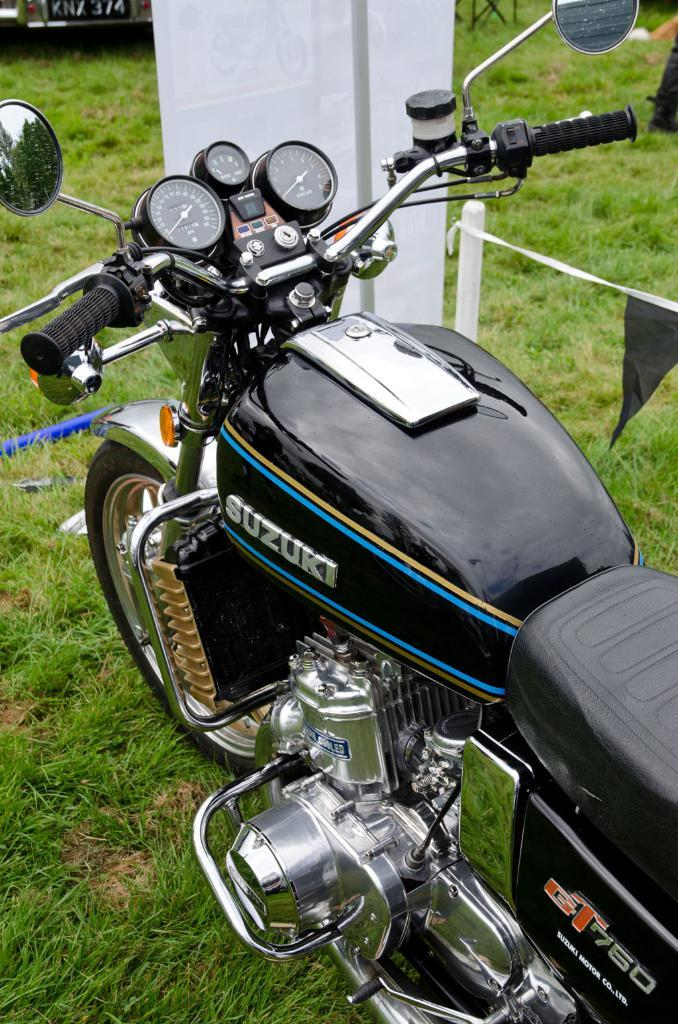What is the main object in the image? There is a bike in the image. Where is the bike located? The bike is on the grass. Is there any additional object or feature related to the bike? Yes, there is a banner in the image, and it is at the front of the bike. What type of brass instrument can be seen in the image? There is no brass instrument present in the image; it features a bike on the grass with a banner at the front. 